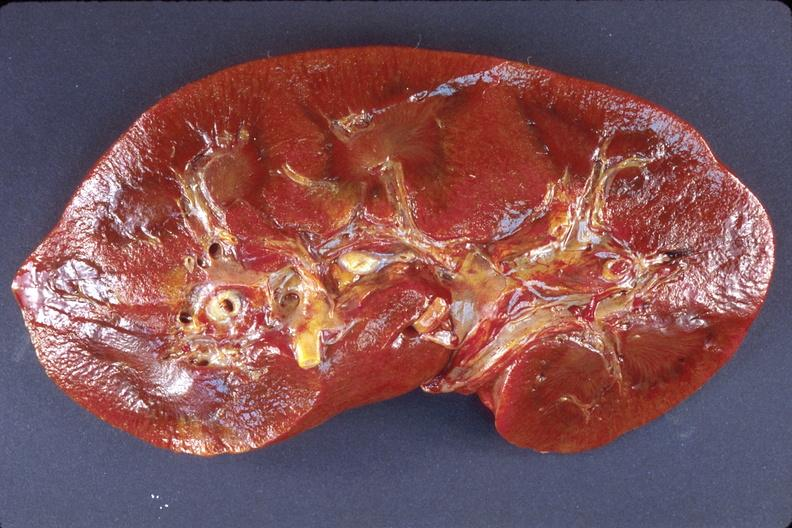what does this image show?
Answer the question using a single word or phrase. Kidney 